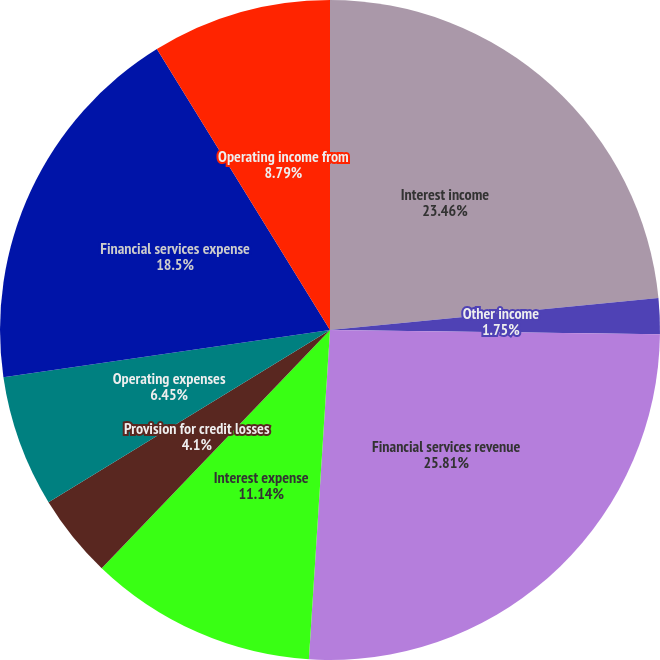Convert chart to OTSL. <chart><loc_0><loc_0><loc_500><loc_500><pie_chart><fcel>Interest income<fcel>Other income<fcel>Financial services revenue<fcel>Interest expense<fcel>Provision for credit losses<fcel>Operating expenses<fcel>Financial services expense<fcel>Operating income from<nl><fcel>23.46%<fcel>1.75%<fcel>25.81%<fcel>11.14%<fcel>4.1%<fcel>6.45%<fcel>18.5%<fcel>8.79%<nl></chart> 